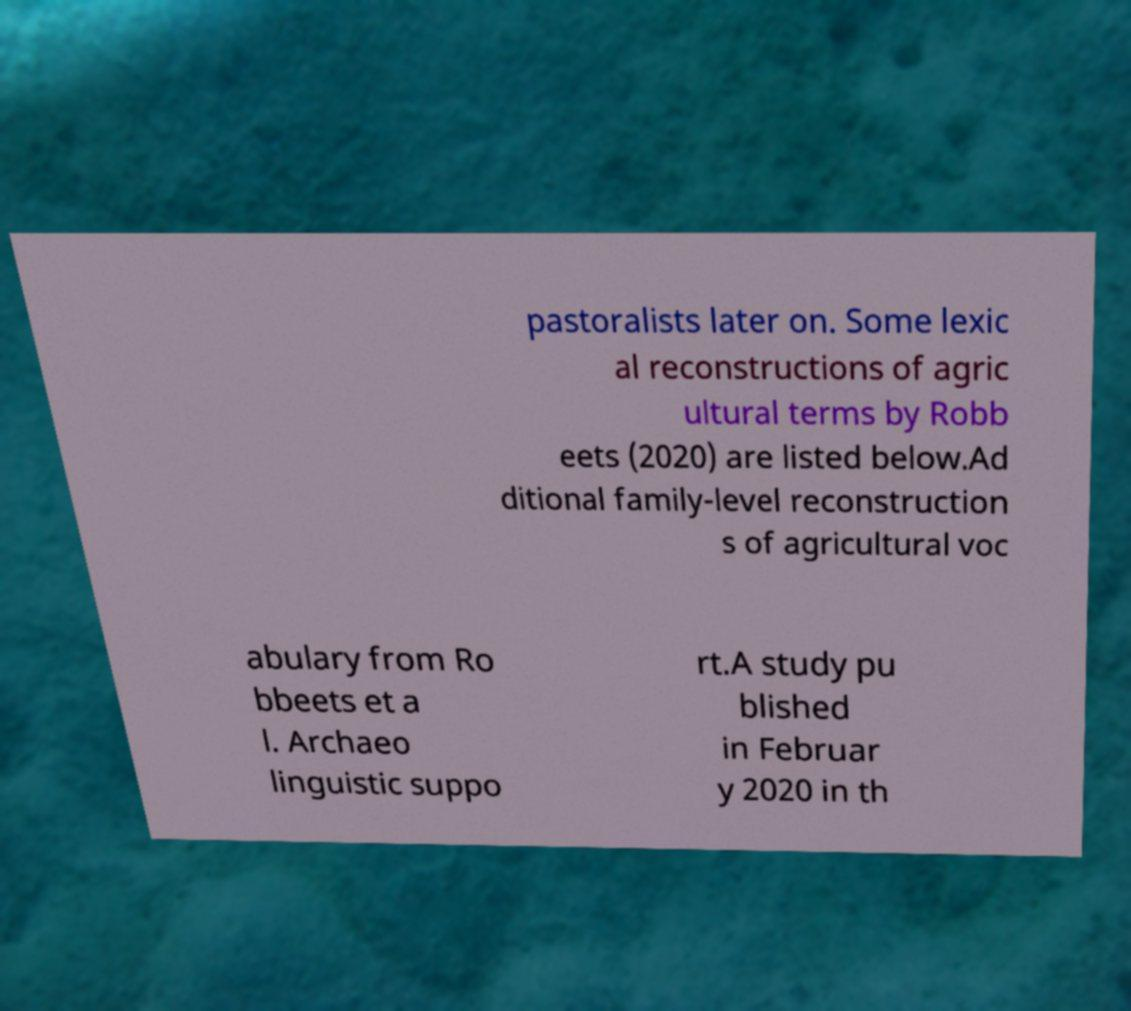Please read and relay the text visible in this image. What does it say? pastoralists later on. Some lexic al reconstructions of agric ultural terms by Robb eets (2020) are listed below.Ad ditional family-level reconstruction s of agricultural voc abulary from Ro bbeets et a l. Archaeo linguistic suppo rt.A study pu blished in Februar y 2020 in th 